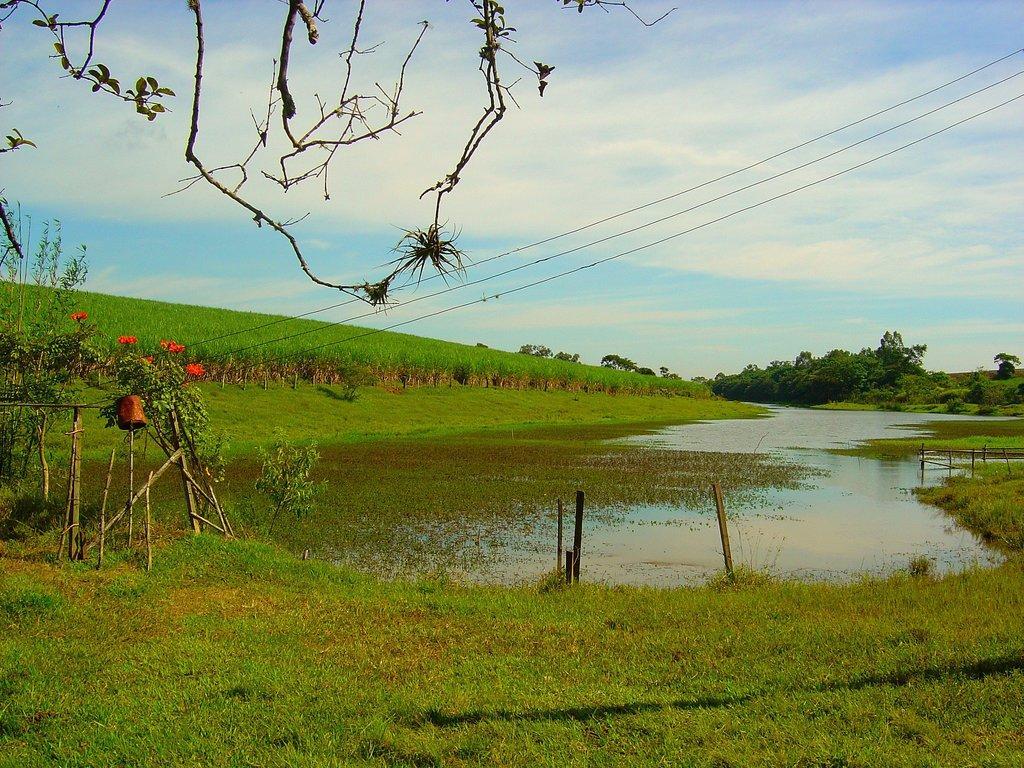Please provide a concise description of this image. In the center of the image we can see water. At the bottom of the image there is grass. On the left side of the image we can see plants and flowers. In the background we can see plants, grass, trees, sky and clouds. 